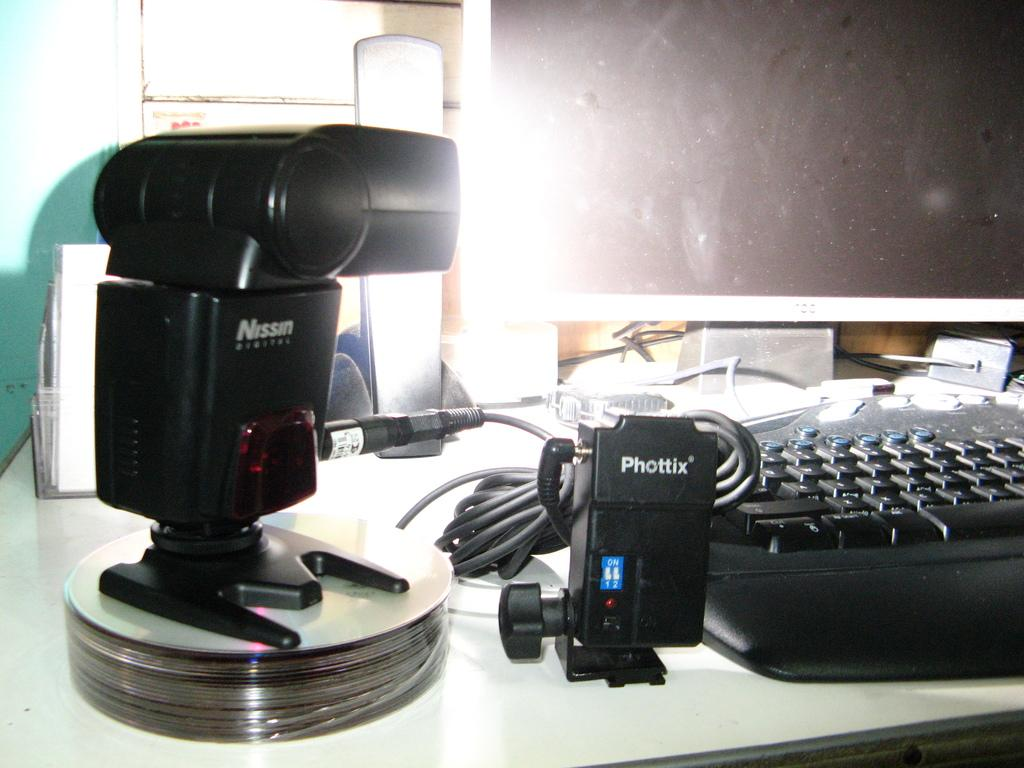Provide a one-sentence caption for the provided image. A Nissin camera or camera lens sits on top of some CD's next to an electronic labeled Phottix. 